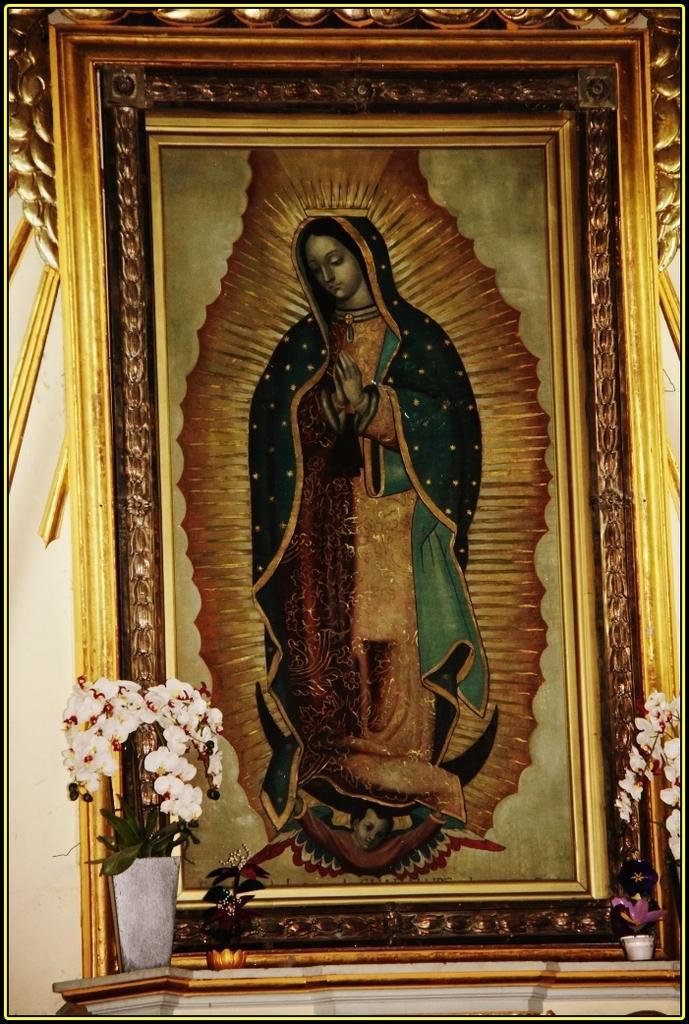Please provide a concise description of this image. In this image I can see a frame which consists of a painting of a person. At the bottom there are few flower pots. 